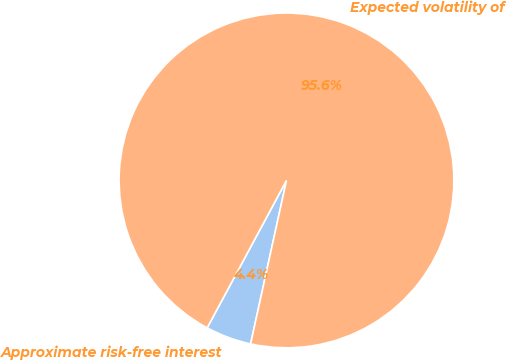Convert chart to OTSL. <chart><loc_0><loc_0><loc_500><loc_500><pie_chart><fcel>Approximate risk-free interest<fcel>Expected volatility of<nl><fcel>4.42%<fcel>95.58%<nl></chart> 